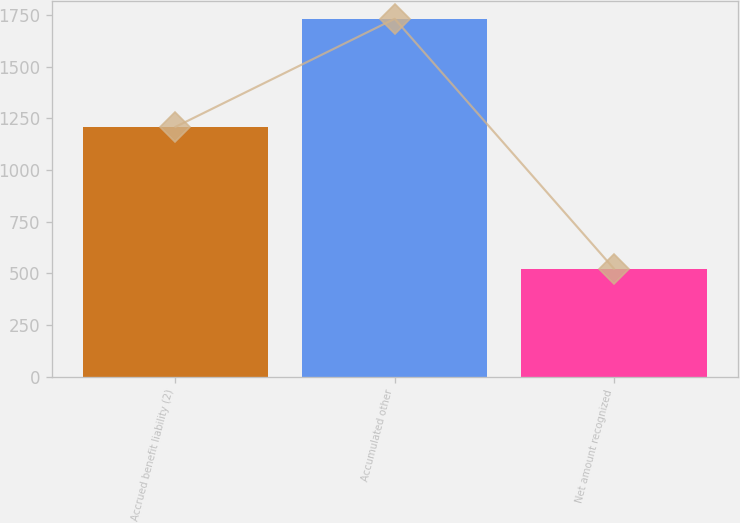Convert chart. <chart><loc_0><loc_0><loc_500><loc_500><bar_chart><fcel>Accrued benefit liability (2)<fcel>Accumulated other<fcel>Net amount recognized<nl><fcel>1209<fcel>1732<fcel>523<nl></chart> 